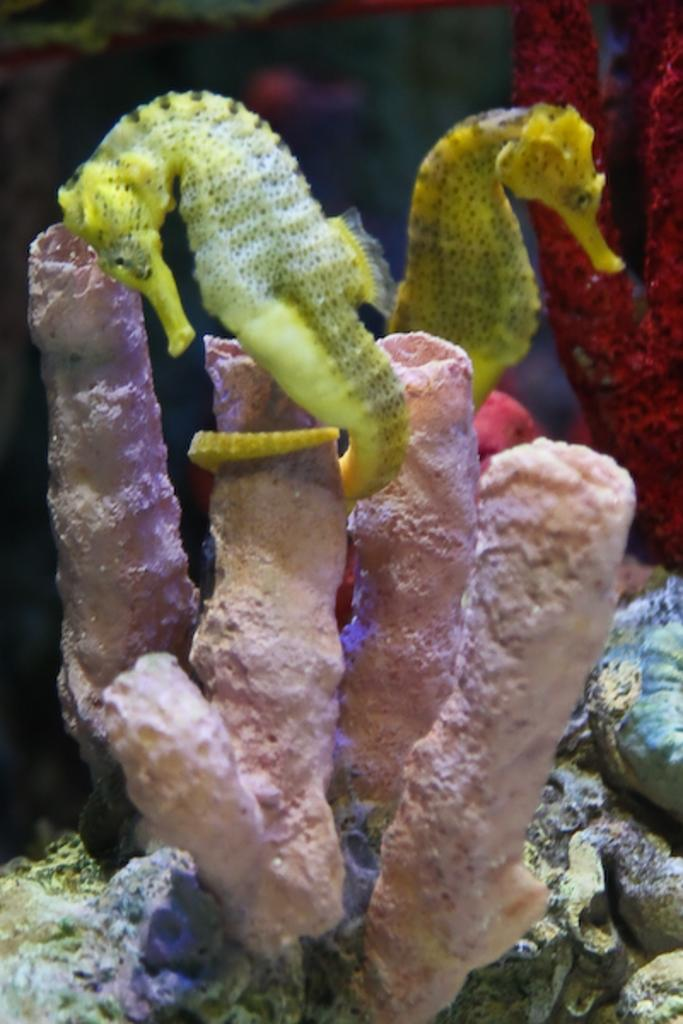What type of environment is shown in the image? The image depicts an underwater environment. What kind of creatures can be seen in the image? There are water animals present in the image. How many divisions are visible in the island shown in the image? There is no island present in the image, as it depicts an underwater environment. 